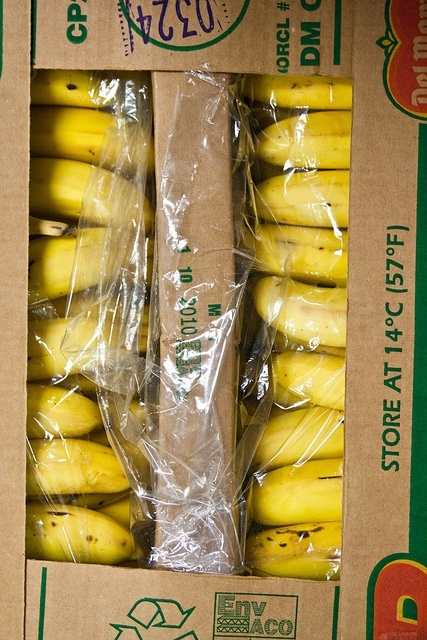Describe the objects in this image and their specific colors. I can see banana in darkgreen, olive, tan, and khaki tones, banana in darkgreen, gold, and olive tones, banana in darkgreen, gold, and olive tones, banana in darkgreen, khaki, gold, and olive tones, and banana in darkgreen, khaki, tan, and olive tones in this image. 